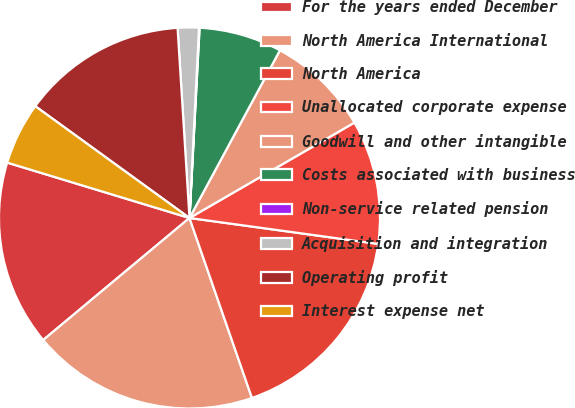Convert chart to OTSL. <chart><loc_0><loc_0><loc_500><loc_500><pie_chart><fcel>For the years ended December<fcel>North America International<fcel>North America<fcel>Unallocated corporate expense<fcel>Goodwill and other intangible<fcel>Costs associated with business<fcel>Non-service related pension<fcel>Acquisition and integration<fcel>Operating profit<fcel>Interest expense net<nl><fcel>15.76%<fcel>19.25%<fcel>17.51%<fcel>10.52%<fcel>8.78%<fcel>7.03%<fcel>0.05%<fcel>1.79%<fcel>14.02%<fcel>5.29%<nl></chart> 